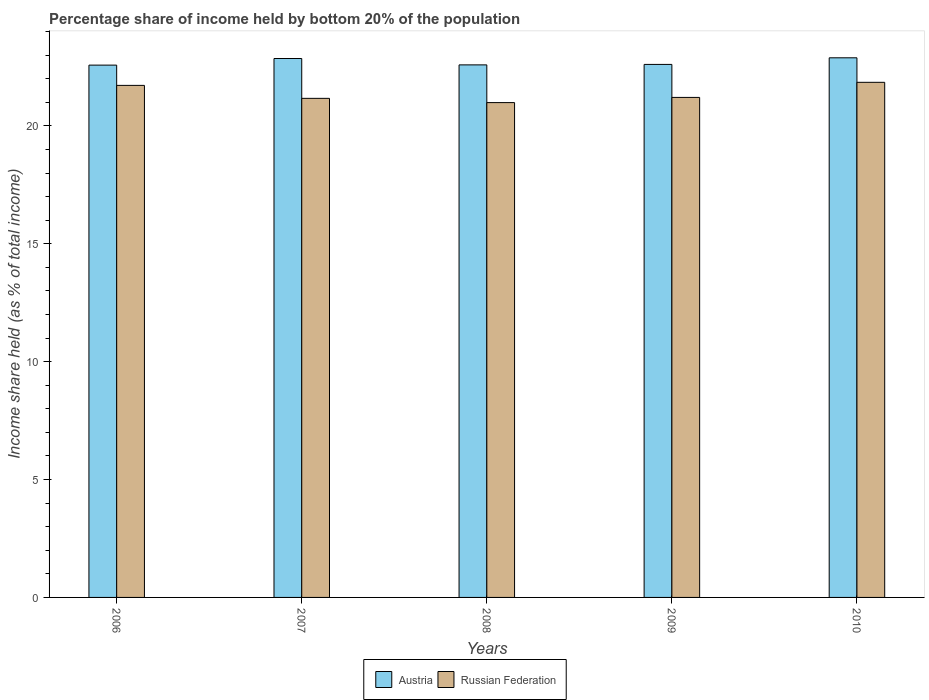How many different coloured bars are there?
Offer a very short reply. 2. How many groups of bars are there?
Your response must be concise. 5. What is the label of the 2nd group of bars from the left?
Offer a very short reply. 2007. What is the share of income held by bottom 20% of the population in Russian Federation in 2008?
Keep it short and to the point. 20.99. Across all years, what is the maximum share of income held by bottom 20% of the population in Austria?
Offer a terse response. 22.89. Across all years, what is the minimum share of income held by bottom 20% of the population in Austria?
Provide a short and direct response. 22.58. In which year was the share of income held by bottom 20% of the population in Russian Federation minimum?
Offer a terse response. 2008. What is the total share of income held by bottom 20% of the population in Austria in the graph?
Your answer should be very brief. 113.53. What is the difference between the share of income held by bottom 20% of the population in Austria in 2006 and that in 2007?
Provide a succinct answer. -0.28. What is the difference between the share of income held by bottom 20% of the population in Austria in 2009 and the share of income held by bottom 20% of the population in Russian Federation in 2006?
Keep it short and to the point. 0.89. What is the average share of income held by bottom 20% of the population in Russian Federation per year?
Make the answer very short. 21.39. In the year 2008, what is the difference between the share of income held by bottom 20% of the population in Russian Federation and share of income held by bottom 20% of the population in Austria?
Keep it short and to the point. -1.6. What is the ratio of the share of income held by bottom 20% of the population in Austria in 2008 to that in 2009?
Ensure brevity in your answer.  1. Is the difference between the share of income held by bottom 20% of the population in Russian Federation in 2006 and 2007 greater than the difference between the share of income held by bottom 20% of the population in Austria in 2006 and 2007?
Your response must be concise. Yes. What is the difference between the highest and the second highest share of income held by bottom 20% of the population in Russian Federation?
Offer a terse response. 0.13. What is the difference between the highest and the lowest share of income held by bottom 20% of the population in Austria?
Your answer should be very brief. 0.31. In how many years, is the share of income held by bottom 20% of the population in Russian Federation greater than the average share of income held by bottom 20% of the population in Russian Federation taken over all years?
Make the answer very short. 2. Is the sum of the share of income held by bottom 20% of the population in Austria in 2006 and 2009 greater than the maximum share of income held by bottom 20% of the population in Russian Federation across all years?
Ensure brevity in your answer.  Yes. What does the 2nd bar from the left in 2007 represents?
Provide a short and direct response. Russian Federation. How many years are there in the graph?
Your response must be concise. 5. Where does the legend appear in the graph?
Offer a terse response. Bottom center. How many legend labels are there?
Keep it short and to the point. 2. What is the title of the graph?
Keep it short and to the point. Percentage share of income held by bottom 20% of the population. Does "Togo" appear as one of the legend labels in the graph?
Provide a succinct answer. No. What is the label or title of the Y-axis?
Provide a short and direct response. Income share held (as % of total income). What is the Income share held (as % of total income) of Austria in 2006?
Ensure brevity in your answer.  22.58. What is the Income share held (as % of total income) in Russian Federation in 2006?
Your answer should be compact. 21.72. What is the Income share held (as % of total income) in Austria in 2007?
Make the answer very short. 22.86. What is the Income share held (as % of total income) of Russian Federation in 2007?
Make the answer very short. 21.17. What is the Income share held (as % of total income) in Austria in 2008?
Keep it short and to the point. 22.59. What is the Income share held (as % of total income) of Russian Federation in 2008?
Your answer should be compact. 20.99. What is the Income share held (as % of total income) in Austria in 2009?
Your answer should be very brief. 22.61. What is the Income share held (as % of total income) in Russian Federation in 2009?
Offer a terse response. 21.21. What is the Income share held (as % of total income) in Austria in 2010?
Give a very brief answer. 22.89. What is the Income share held (as % of total income) of Russian Federation in 2010?
Offer a terse response. 21.85. Across all years, what is the maximum Income share held (as % of total income) of Austria?
Ensure brevity in your answer.  22.89. Across all years, what is the maximum Income share held (as % of total income) in Russian Federation?
Make the answer very short. 21.85. Across all years, what is the minimum Income share held (as % of total income) of Austria?
Give a very brief answer. 22.58. Across all years, what is the minimum Income share held (as % of total income) in Russian Federation?
Offer a very short reply. 20.99. What is the total Income share held (as % of total income) of Austria in the graph?
Your answer should be compact. 113.53. What is the total Income share held (as % of total income) in Russian Federation in the graph?
Provide a short and direct response. 106.94. What is the difference between the Income share held (as % of total income) in Austria in 2006 and that in 2007?
Provide a succinct answer. -0.28. What is the difference between the Income share held (as % of total income) of Russian Federation in 2006 and that in 2007?
Provide a succinct answer. 0.55. What is the difference between the Income share held (as % of total income) of Austria in 2006 and that in 2008?
Make the answer very short. -0.01. What is the difference between the Income share held (as % of total income) in Russian Federation in 2006 and that in 2008?
Provide a short and direct response. 0.73. What is the difference between the Income share held (as % of total income) of Austria in 2006 and that in 2009?
Offer a terse response. -0.03. What is the difference between the Income share held (as % of total income) of Russian Federation in 2006 and that in 2009?
Provide a short and direct response. 0.51. What is the difference between the Income share held (as % of total income) in Austria in 2006 and that in 2010?
Keep it short and to the point. -0.31. What is the difference between the Income share held (as % of total income) of Russian Federation in 2006 and that in 2010?
Provide a short and direct response. -0.13. What is the difference between the Income share held (as % of total income) in Austria in 2007 and that in 2008?
Offer a very short reply. 0.27. What is the difference between the Income share held (as % of total income) of Russian Federation in 2007 and that in 2008?
Your answer should be very brief. 0.18. What is the difference between the Income share held (as % of total income) of Russian Federation in 2007 and that in 2009?
Offer a very short reply. -0.04. What is the difference between the Income share held (as % of total income) of Austria in 2007 and that in 2010?
Provide a short and direct response. -0.03. What is the difference between the Income share held (as % of total income) in Russian Federation in 2007 and that in 2010?
Offer a terse response. -0.68. What is the difference between the Income share held (as % of total income) in Austria in 2008 and that in 2009?
Your answer should be compact. -0.02. What is the difference between the Income share held (as % of total income) in Russian Federation in 2008 and that in 2009?
Provide a succinct answer. -0.22. What is the difference between the Income share held (as % of total income) in Russian Federation in 2008 and that in 2010?
Offer a very short reply. -0.86. What is the difference between the Income share held (as % of total income) of Austria in 2009 and that in 2010?
Give a very brief answer. -0.28. What is the difference between the Income share held (as % of total income) in Russian Federation in 2009 and that in 2010?
Make the answer very short. -0.64. What is the difference between the Income share held (as % of total income) of Austria in 2006 and the Income share held (as % of total income) of Russian Federation in 2007?
Your answer should be very brief. 1.41. What is the difference between the Income share held (as % of total income) in Austria in 2006 and the Income share held (as % of total income) in Russian Federation in 2008?
Your response must be concise. 1.59. What is the difference between the Income share held (as % of total income) in Austria in 2006 and the Income share held (as % of total income) in Russian Federation in 2009?
Your response must be concise. 1.37. What is the difference between the Income share held (as % of total income) of Austria in 2006 and the Income share held (as % of total income) of Russian Federation in 2010?
Offer a very short reply. 0.73. What is the difference between the Income share held (as % of total income) in Austria in 2007 and the Income share held (as % of total income) in Russian Federation in 2008?
Your answer should be very brief. 1.87. What is the difference between the Income share held (as % of total income) of Austria in 2007 and the Income share held (as % of total income) of Russian Federation in 2009?
Give a very brief answer. 1.65. What is the difference between the Income share held (as % of total income) of Austria in 2007 and the Income share held (as % of total income) of Russian Federation in 2010?
Offer a very short reply. 1.01. What is the difference between the Income share held (as % of total income) of Austria in 2008 and the Income share held (as % of total income) of Russian Federation in 2009?
Make the answer very short. 1.38. What is the difference between the Income share held (as % of total income) in Austria in 2008 and the Income share held (as % of total income) in Russian Federation in 2010?
Your answer should be very brief. 0.74. What is the difference between the Income share held (as % of total income) in Austria in 2009 and the Income share held (as % of total income) in Russian Federation in 2010?
Your answer should be compact. 0.76. What is the average Income share held (as % of total income) of Austria per year?
Offer a very short reply. 22.71. What is the average Income share held (as % of total income) of Russian Federation per year?
Give a very brief answer. 21.39. In the year 2006, what is the difference between the Income share held (as % of total income) in Austria and Income share held (as % of total income) in Russian Federation?
Your response must be concise. 0.86. In the year 2007, what is the difference between the Income share held (as % of total income) of Austria and Income share held (as % of total income) of Russian Federation?
Offer a terse response. 1.69. What is the ratio of the Income share held (as % of total income) in Russian Federation in 2006 to that in 2007?
Keep it short and to the point. 1.03. What is the ratio of the Income share held (as % of total income) of Austria in 2006 to that in 2008?
Ensure brevity in your answer.  1. What is the ratio of the Income share held (as % of total income) of Russian Federation in 2006 to that in 2008?
Provide a succinct answer. 1.03. What is the ratio of the Income share held (as % of total income) in Austria in 2006 to that in 2009?
Offer a terse response. 1. What is the ratio of the Income share held (as % of total income) of Russian Federation in 2006 to that in 2009?
Your response must be concise. 1.02. What is the ratio of the Income share held (as % of total income) of Austria in 2006 to that in 2010?
Make the answer very short. 0.99. What is the ratio of the Income share held (as % of total income) of Russian Federation in 2006 to that in 2010?
Your answer should be very brief. 0.99. What is the ratio of the Income share held (as % of total income) in Austria in 2007 to that in 2008?
Ensure brevity in your answer.  1.01. What is the ratio of the Income share held (as % of total income) in Russian Federation in 2007 to that in 2008?
Provide a short and direct response. 1.01. What is the ratio of the Income share held (as % of total income) of Austria in 2007 to that in 2009?
Provide a succinct answer. 1.01. What is the ratio of the Income share held (as % of total income) of Russian Federation in 2007 to that in 2010?
Give a very brief answer. 0.97. What is the ratio of the Income share held (as % of total income) in Russian Federation in 2008 to that in 2009?
Ensure brevity in your answer.  0.99. What is the ratio of the Income share held (as % of total income) in Austria in 2008 to that in 2010?
Keep it short and to the point. 0.99. What is the ratio of the Income share held (as % of total income) in Russian Federation in 2008 to that in 2010?
Provide a succinct answer. 0.96. What is the ratio of the Income share held (as % of total income) of Austria in 2009 to that in 2010?
Offer a very short reply. 0.99. What is the ratio of the Income share held (as % of total income) of Russian Federation in 2009 to that in 2010?
Provide a succinct answer. 0.97. What is the difference between the highest and the second highest Income share held (as % of total income) of Russian Federation?
Keep it short and to the point. 0.13. What is the difference between the highest and the lowest Income share held (as % of total income) in Austria?
Offer a terse response. 0.31. What is the difference between the highest and the lowest Income share held (as % of total income) in Russian Federation?
Offer a very short reply. 0.86. 